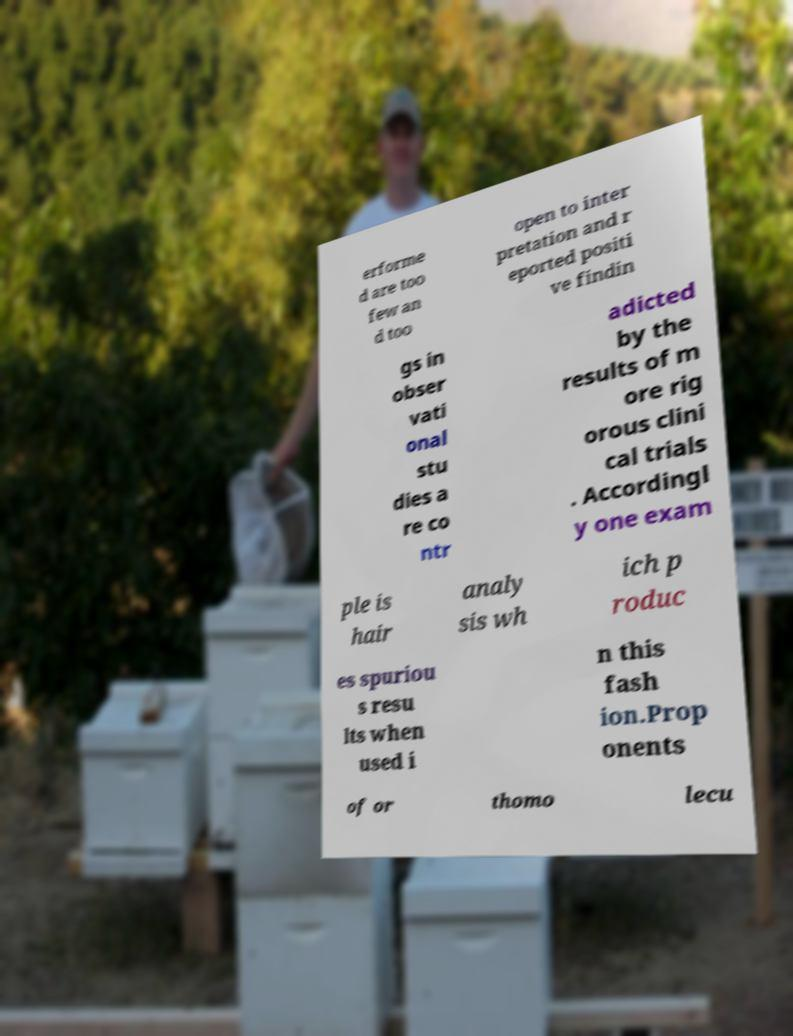Could you extract and type out the text from this image? erforme d are too few an d too open to inter pretation and r eported positi ve findin gs in obser vati onal stu dies a re co ntr adicted by the results of m ore rig orous clini cal trials . Accordingl y one exam ple is hair analy sis wh ich p roduc es spuriou s resu lts when used i n this fash ion.Prop onents of or thomo lecu 